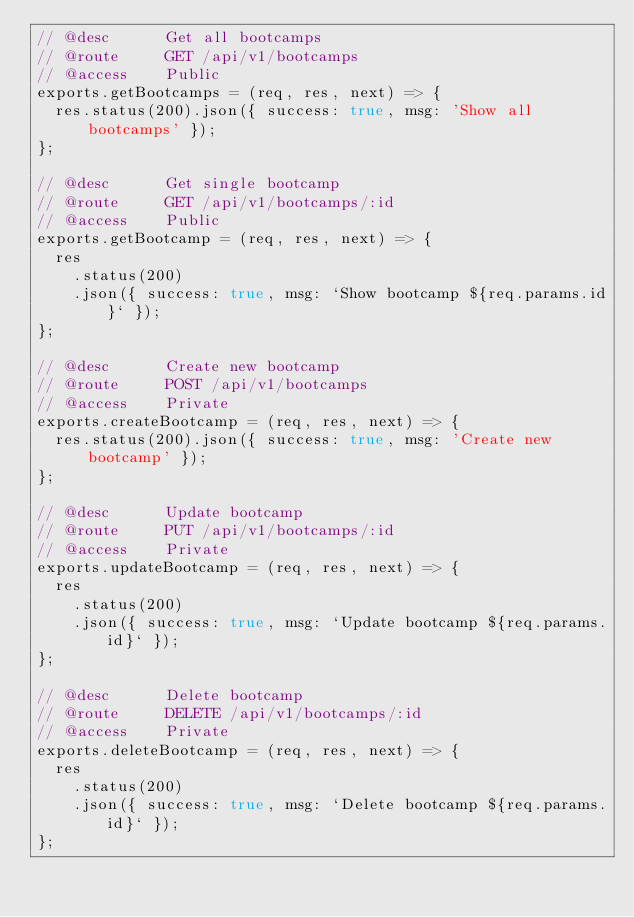Convert code to text. <code><loc_0><loc_0><loc_500><loc_500><_JavaScript_>// @desc      Get all bootcamps
// @route     GET /api/v1/bootcamps
// @access    Public
exports.getBootcamps = (req, res, next) => {
  res.status(200).json({ success: true, msg: 'Show all bootcamps' });
};

// @desc      Get single bootcamp
// @route     GET /api/v1/bootcamps/:id
// @access    Public
exports.getBootcamp = (req, res, next) => {
  res
    .status(200)
    .json({ success: true, msg: `Show bootcamp ${req.params.id}` });
};

// @desc      Create new bootcamp
// @route     POST /api/v1/bootcamps
// @access    Private
exports.createBootcamp = (req, res, next) => {
  res.status(200).json({ success: true, msg: 'Create new bootcamp' });
};

// @desc      Update bootcamp
// @route     PUT /api/v1/bootcamps/:id
// @access    Private
exports.updateBootcamp = (req, res, next) => {
  res
    .status(200)
    .json({ success: true, msg: `Update bootcamp ${req.params.id}` });
};

// @desc      Delete bootcamp
// @route     DELETE /api/v1/bootcamps/:id
// @access    Private
exports.deleteBootcamp = (req, res, next) => {
  res
    .status(200)
    .json({ success: true, msg: `Delete bootcamp ${req.params.id}` });
};
</code> 